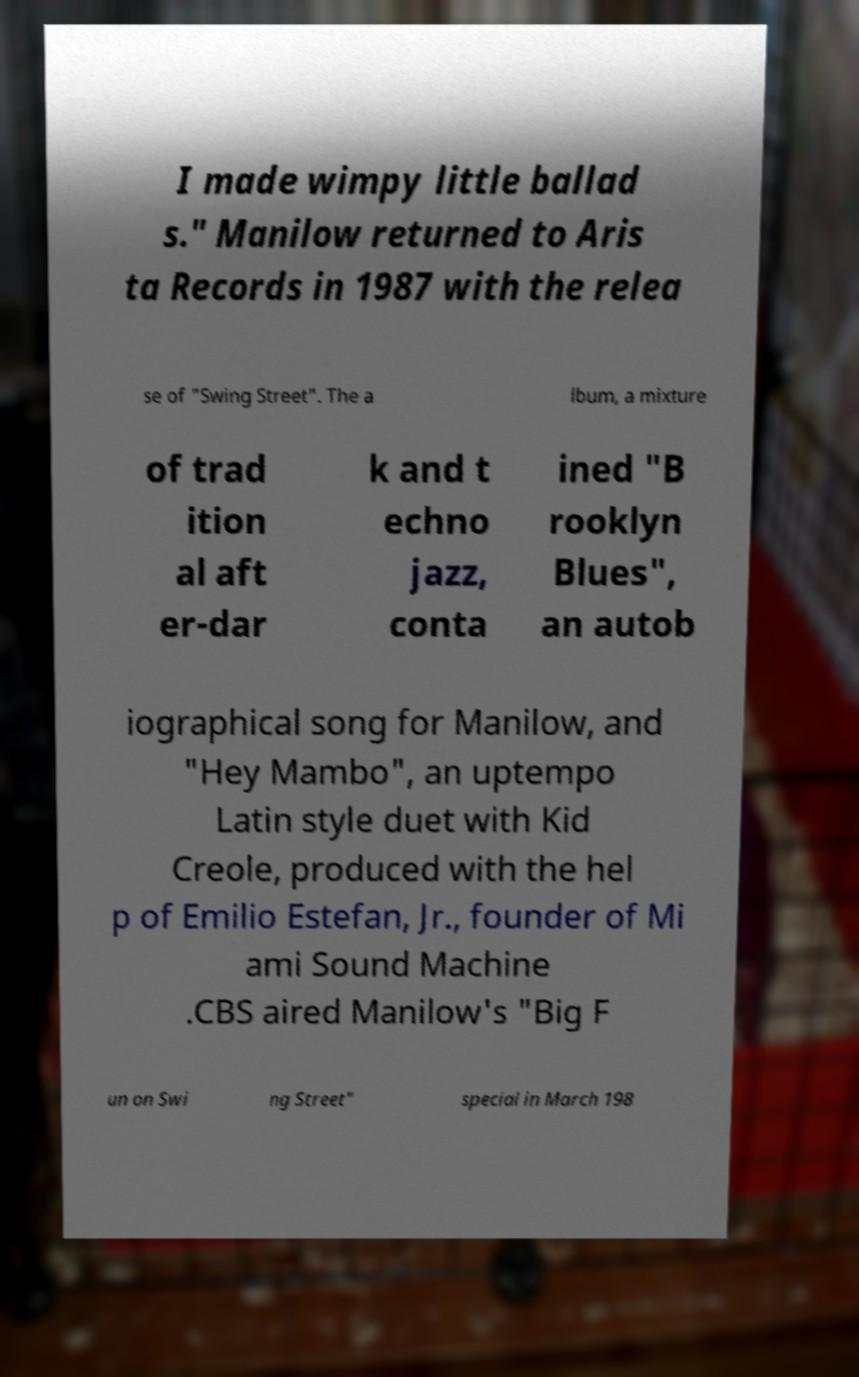Could you extract and type out the text from this image? I made wimpy little ballad s." Manilow returned to Aris ta Records in 1987 with the relea se of "Swing Street". The a lbum, a mixture of trad ition al aft er-dar k and t echno jazz, conta ined "B rooklyn Blues", an autob iographical song for Manilow, and "Hey Mambo", an uptempo Latin style duet with Kid Creole, produced with the hel p of Emilio Estefan, Jr., founder of Mi ami Sound Machine .CBS aired Manilow's "Big F un on Swi ng Street" special in March 198 